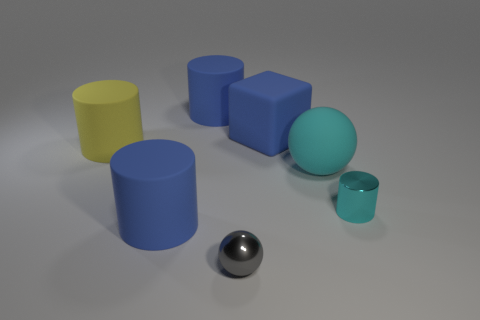Subtract all blue spheres. How many blue cylinders are left? 2 Subtract all large yellow rubber cylinders. How many cylinders are left? 3 Add 1 large yellow shiny cylinders. How many objects exist? 8 Subtract all yellow cylinders. How many cylinders are left? 3 Subtract all spheres. How many objects are left? 5 Subtract all cyan cylinders. Subtract all gray spheres. How many cylinders are left? 3 Add 2 large metal things. How many large metal things exist? 2 Subtract 0 brown blocks. How many objects are left? 7 Subtract all blue rubber cylinders. Subtract all big blue objects. How many objects are left? 2 Add 2 yellow matte cylinders. How many yellow matte cylinders are left? 3 